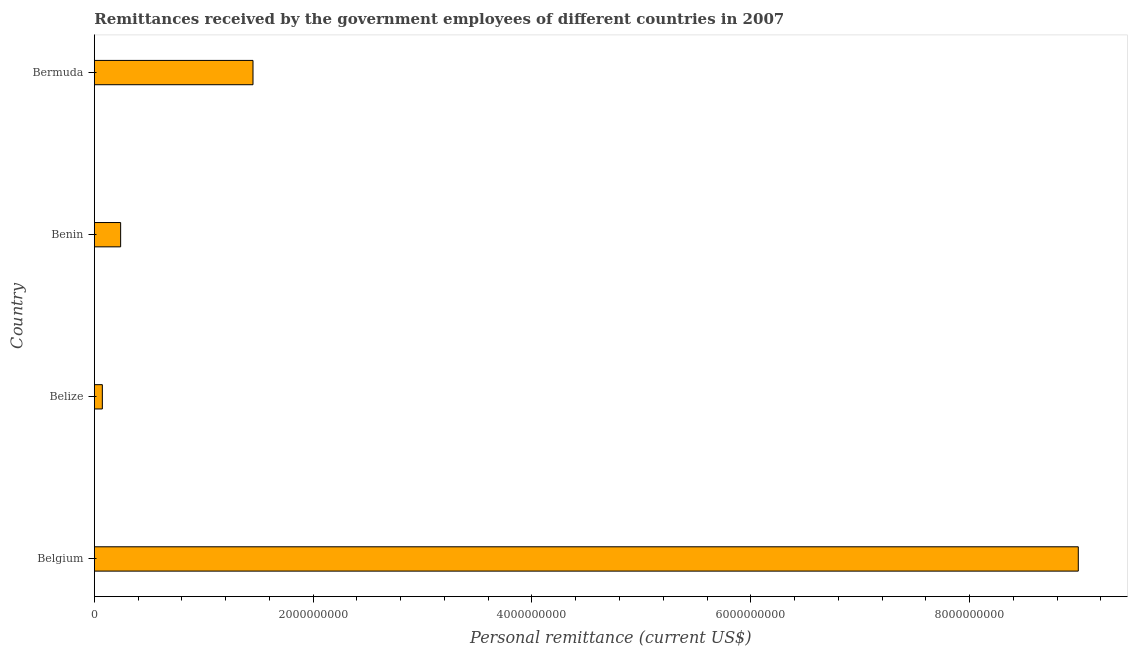Does the graph contain grids?
Provide a short and direct response. No. What is the title of the graph?
Make the answer very short. Remittances received by the government employees of different countries in 2007. What is the label or title of the X-axis?
Offer a terse response. Personal remittance (current US$). What is the label or title of the Y-axis?
Your response must be concise. Country. What is the personal remittances in Belgium?
Offer a very short reply. 8.99e+09. Across all countries, what is the maximum personal remittances?
Ensure brevity in your answer.  8.99e+09. Across all countries, what is the minimum personal remittances?
Keep it short and to the point. 7.31e+07. In which country was the personal remittances minimum?
Your answer should be very brief. Belize. What is the sum of the personal remittances?
Give a very brief answer. 1.08e+1. What is the difference between the personal remittances in Belgium and Belize?
Offer a terse response. 8.92e+09. What is the average personal remittances per country?
Keep it short and to the point. 2.69e+09. What is the median personal remittances?
Ensure brevity in your answer.  8.45e+08. In how many countries, is the personal remittances greater than 2400000000 US$?
Your answer should be compact. 1. What is the ratio of the personal remittances in Belgium to that in Bermuda?
Ensure brevity in your answer.  6.2. Is the personal remittances in Belgium less than that in Bermuda?
Offer a terse response. No. What is the difference between the highest and the second highest personal remittances?
Offer a very short reply. 7.54e+09. Is the sum of the personal remittances in Benin and Bermuda greater than the maximum personal remittances across all countries?
Give a very brief answer. No. What is the difference between the highest and the lowest personal remittances?
Your response must be concise. 8.92e+09. Are all the bars in the graph horizontal?
Your response must be concise. Yes. What is the difference between two consecutive major ticks on the X-axis?
Provide a succinct answer. 2.00e+09. Are the values on the major ticks of X-axis written in scientific E-notation?
Provide a short and direct response. No. What is the Personal remittance (current US$) of Belgium?
Make the answer very short. 8.99e+09. What is the Personal remittance (current US$) in Belize?
Your response must be concise. 7.31e+07. What is the Personal remittance (current US$) of Benin?
Offer a very short reply. 2.40e+08. What is the Personal remittance (current US$) of Bermuda?
Your response must be concise. 1.45e+09. What is the difference between the Personal remittance (current US$) in Belgium and Belize?
Give a very brief answer. 8.92e+09. What is the difference between the Personal remittance (current US$) in Belgium and Benin?
Give a very brief answer. 8.75e+09. What is the difference between the Personal remittance (current US$) in Belgium and Bermuda?
Offer a terse response. 7.54e+09. What is the difference between the Personal remittance (current US$) in Belize and Benin?
Keep it short and to the point. -1.67e+08. What is the difference between the Personal remittance (current US$) in Belize and Bermuda?
Make the answer very short. -1.38e+09. What is the difference between the Personal remittance (current US$) in Benin and Bermuda?
Your answer should be very brief. -1.21e+09. What is the ratio of the Personal remittance (current US$) in Belgium to that in Belize?
Keep it short and to the point. 123. What is the ratio of the Personal remittance (current US$) in Belgium to that in Benin?
Provide a succinct answer. 37.4. What is the ratio of the Personal remittance (current US$) in Belgium to that in Bermuda?
Provide a succinct answer. 6.2. What is the ratio of the Personal remittance (current US$) in Belize to that in Benin?
Offer a terse response. 0.3. What is the ratio of the Personal remittance (current US$) in Benin to that in Bermuda?
Offer a very short reply. 0.17. 